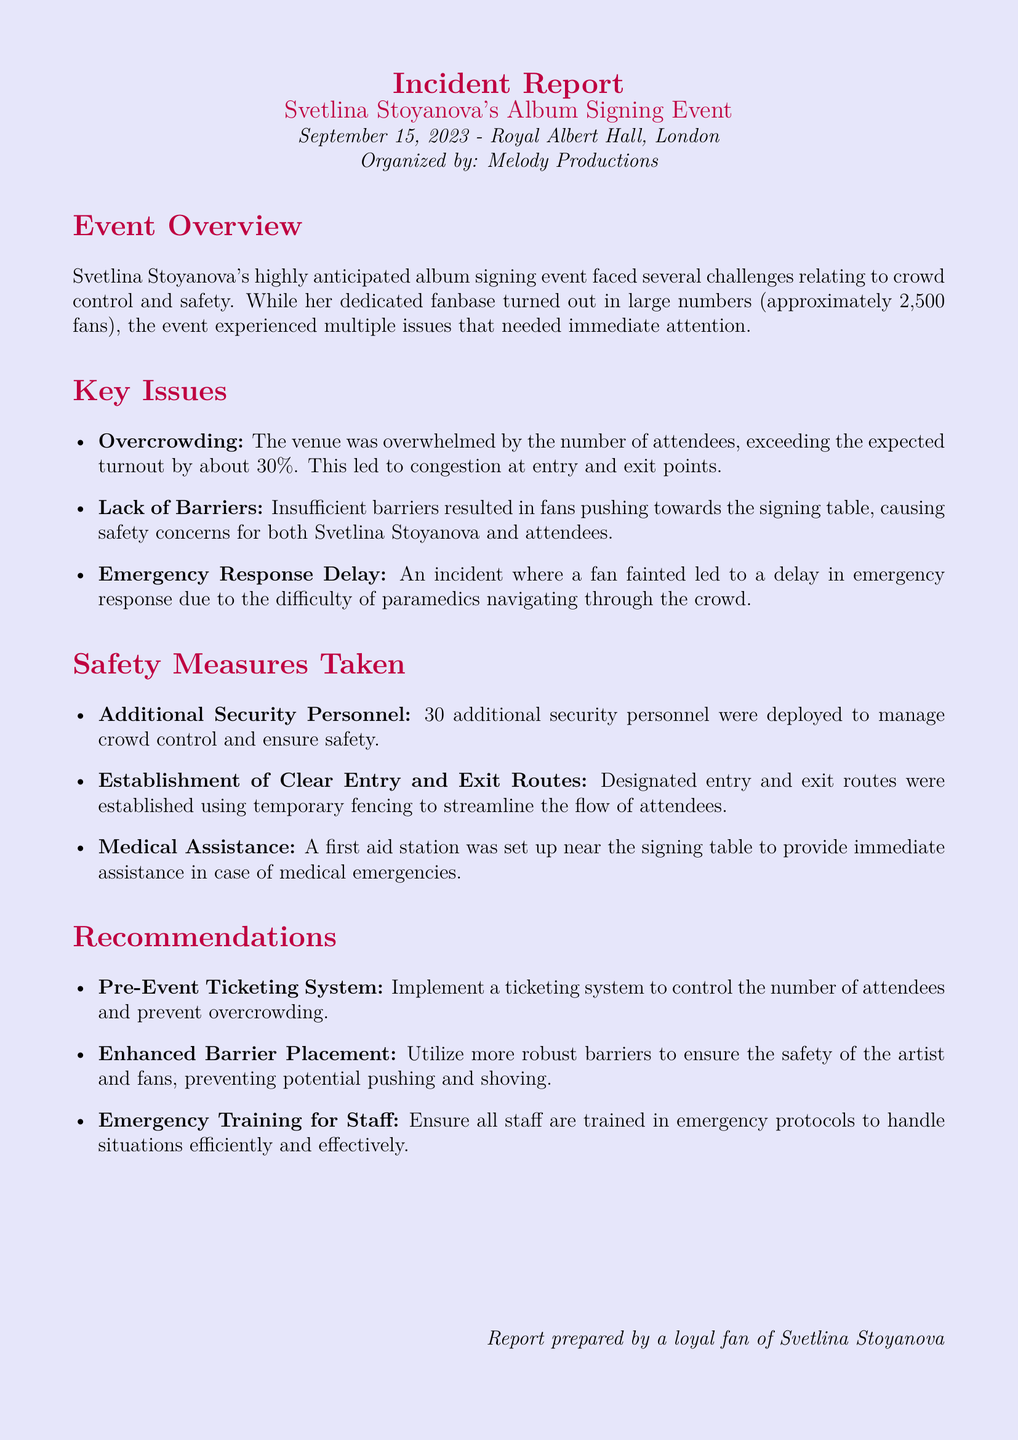what date did the event occur? The event took place on September 15, 2023.
Answer: September 15, 2023 how many fans attended the event? Approximately 2,500 fans attended the event.
Answer: 2,500 fans what was one of the key issues during the event? One of the key issues mentioned is overcrowding at the venue.
Answer: Overcrowding how many additional security personnel were deployed? The document states that 30 additional security personnel were deployed.
Answer: 30 what type of medical assistance was provided? A first aid station was set up near the signing table.
Answer: First aid station what recommendation was made regarding ticketing? The report recommends implementing a pre-event ticketing system.
Answer: Pre-event ticketing system what led to an emergency response delay? An incident where a fan fainted caused the delay in emergency response.
Answer: Fan fainted what was the effect of lack of barriers? Lack of barriers led to fans pushing towards the signing table, causing safety concerns.
Answer: Safety concerns what is the title of the report? The title of the report is "Incident Report".
Answer: Incident Report 